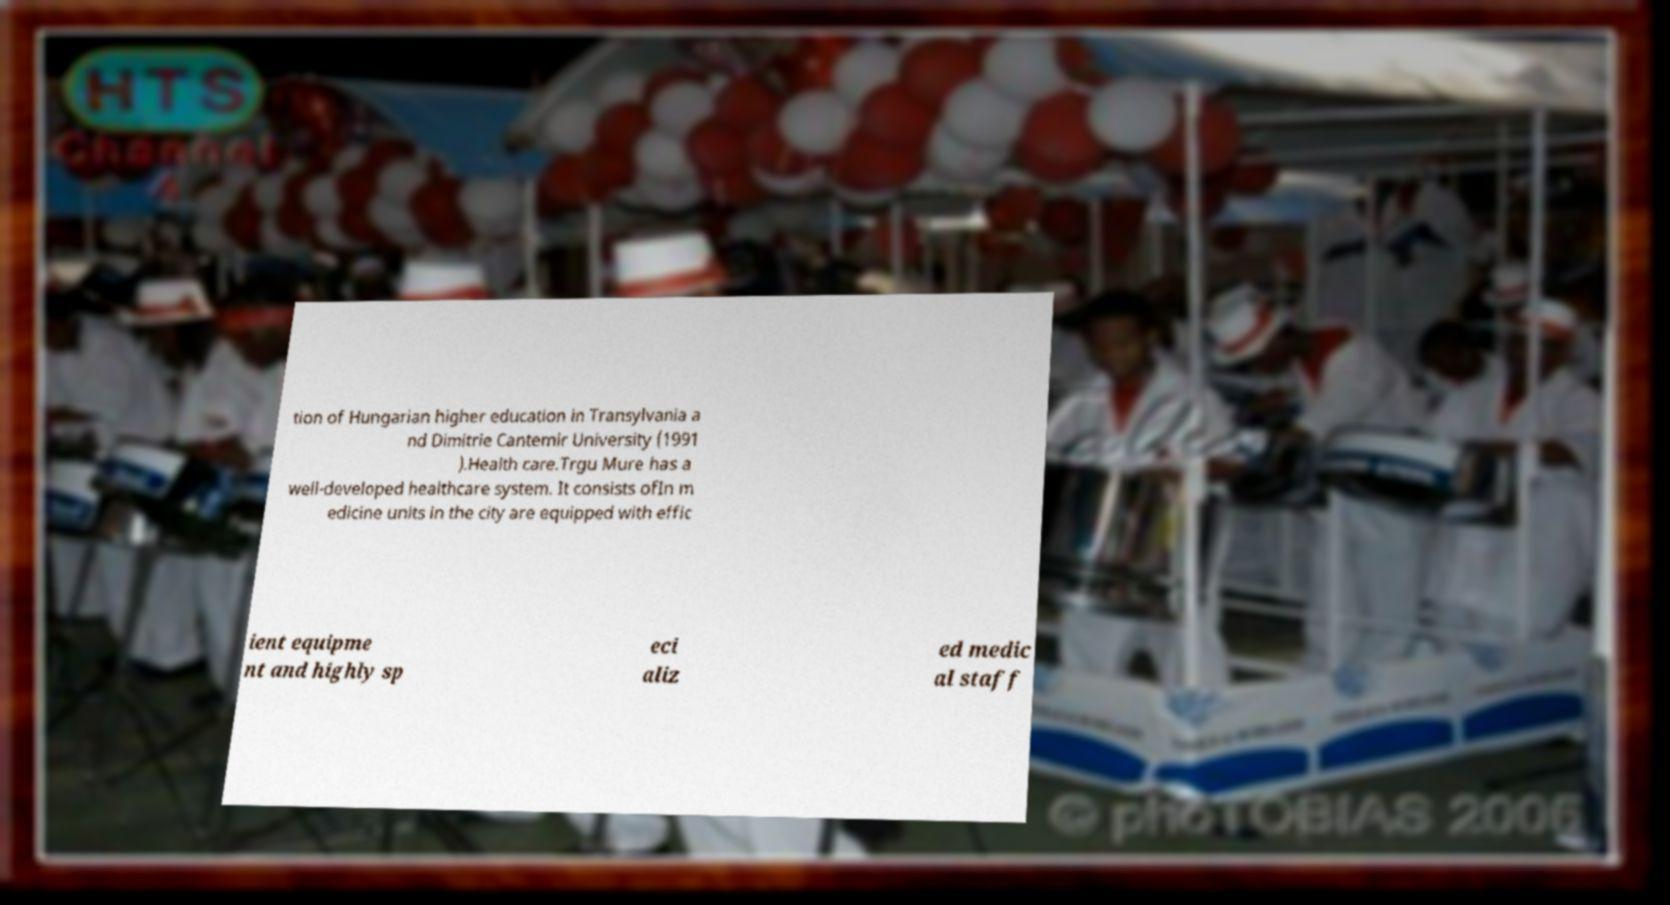I need the written content from this picture converted into text. Can you do that? tion of Hungarian higher education in Transylvania a nd Dimitrie Cantemir University (1991 ).Health care.Trgu Mure has a well-developed healthcare system. It consists ofIn m edicine units in the city are equipped with effic ient equipme nt and highly sp eci aliz ed medic al staff 